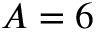Convert formula to latex. <formula><loc_0><loc_0><loc_500><loc_500>A = 6</formula> 